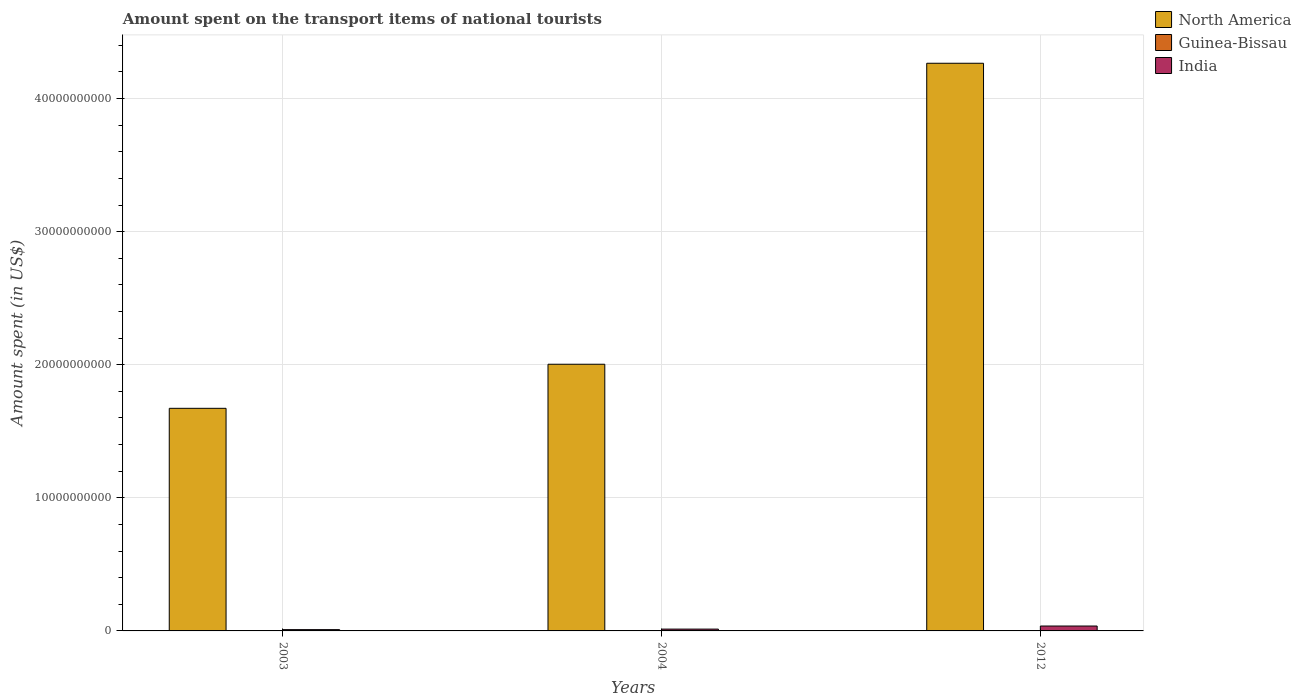Are the number of bars per tick equal to the number of legend labels?
Keep it short and to the point. Yes. Are the number of bars on each tick of the X-axis equal?
Offer a terse response. Yes. How many bars are there on the 1st tick from the left?
Your answer should be compact. 3. How many bars are there on the 3rd tick from the right?
Make the answer very short. 3. In how many cases, is the number of bars for a given year not equal to the number of legend labels?
Make the answer very short. 0. What is the amount spent on the transport items of national tourists in North America in 2004?
Keep it short and to the point. 2.00e+1. Across all years, what is the maximum amount spent on the transport items of national tourists in India?
Offer a terse response. 3.68e+08. In which year was the amount spent on the transport items of national tourists in India maximum?
Make the answer very short. 2012. What is the total amount spent on the transport items of national tourists in North America in the graph?
Ensure brevity in your answer.  7.94e+1. What is the difference between the amount spent on the transport items of national tourists in North America in 2004 and that in 2012?
Make the answer very short. -2.26e+1. What is the difference between the amount spent on the transport items of national tourists in Guinea-Bissau in 2003 and the amount spent on the transport items of national tourists in India in 2004?
Your answer should be very brief. -1.36e+08. What is the average amount spent on the transport items of national tourists in North America per year?
Offer a very short reply. 2.65e+1. In the year 2012, what is the difference between the amount spent on the transport items of national tourists in Guinea-Bissau and amount spent on the transport items of national tourists in North America?
Your answer should be very brief. -4.27e+1. In how many years, is the amount spent on the transport items of national tourists in India greater than 6000000000 US$?
Provide a short and direct response. 0. What is the ratio of the amount spent on the transport items of national tourists in India in 2004 to that in 2012?
Make the answer very short. 0.37. Is the difference between the amount spent on the transport items of national tourists in Guinea-Bissau in 2003 and 2004 greater than the difference between the amount spent on the transport items of national tourists in North America in 2003 and 2004?
Your response must be concise. Yes. What is the difference between the highest and the lowest amount spent on the transport items of national tourists in Guinea-Bissau?
Make the answer very short. 1.00e+06. What does the 2nd bar from the left in 2004 represents?
Your answer should be very brief. Guinea-Bissau. Is it the case that in every year, the sum of the amount spent on the transport items of national tourists in Guinea-Bissau and amount spent on the transport items of national tourists in India is greater than the amount spent on the transport items of national tourists in North America?
Make the answer very short. No. How many bars are there?
Give a very brief answer. 9. Are all the bars in the graph horizontal?
Your response must be concise. No. How many years are there in the graph?
Offer a terse response. 3. What is the difference between two consecutive major ticks on the Y-axis?
Ensure brevity in your answer.  1.00e+1. Are the values on the major ticks of Y-axis written in scientific E-notation?
Provide a succinct answer. No. Does the graph contain grids?
Offer a very short reply. Yes. Where does the legend appear in the graph?
Keep it short and to the point. Top right. How many legend labels are there?
Provide a short and direct response. 3. What is the title of the graph?
Your answer should be very brief. Amount spent on the transport items of national tourists. Does "Bolivia" appear as one of the legend labels in the graph?
Make the answer very short. No. What is the label or title of the Y-axis?
Keep it short and to the point. Amount spent (in US$). What is the Amount spent (in US$) in North America in 2003?
Offer a very short reply. 1.67e+1. What is the Amount spent (in US$) of Guinea-Bissau in 2003?
Provide a short and direct response. 6.00e+05. What is the Amount spent (in US$) in India in 2003?
Your answer should be very brief. 9.70e+07. What is the Amount spent (in US$) in North America in 2004?
Keep it short and to the point. 2.00e+1. What is the Amount spent (in US$) in Guinea-Bissau in 2004?
Your answer should be compact. 1.20e+06. What is the Amount spent (in US$) in India in 2004?
Your answer should be very brief. 1.37e+08. What is the Amount spent (in US$) in North America in 2012?
Ensure brevity in your answer.  4.27e+1. What is the Amount spent (in US$) in India in 2012?
Your answer should be very brief. 3.68e+08. Across all years, what is the maximum Amount spent (in US$) in North America?
Give a very brief answer. 4.27e+1. Across all years, what is the maximum Amount spent (in US$) in Guinea-Bissau?
Your answer should be compact. 1.20e+06. Across all years, what is the maximum Amount spent (in US$) in India?
Provide a short and direct response. 3.68e+08. Across all years, what is the minimum Amount spent (in US$) of North America?
Keep it short and to the point. 1.67e+1. Across all years, what is the minimum Amount spent (in US$) in Guinea-Bissau?
Ensure brevity in your answer.  2.00e+05. Across all years, what is the minimum Amount spent (in US$) in India?
Your answer should be very brief. 9.70e+07. What is the total Amount spent (in US$) of North America in the graph?
Provide a short and direct response. 7.94e+1. What is the total Amount spent (in US$) of Guinea-Bissau in the graph?
Keep it short and to the point. 2.00e+06. What is the total Amount spent (in US$) in India in the graph?
Offer a terse response. 6.02e+08. What is the difference between the Amount spent (in US$) of North America in 2003 and that in 2004?
Your answer should be very brief. -3.31e+09. What is the difference between the Amount spent (in US$) in Guinea-Bissau in 2003 and that in 2004?
Offer a very short reply. -6.00e+05. What is the difference between the Amount spent (in US$) of India in 2003 and that in 2004?
Provide a short and direct response. -4.00e+07. What is the difference between the Amount spent (in US$) of North America in 2003 and that in 2012?
Make the answer very short. -2.59e+1. What is the difference between the Amount spent (in US$) in India in 2003 and that in 2012?
Ensure brevity in your answer.  -2.71e+08. What is the difference between the Amount spent (in US$) in North America in 2004 and that in 2012?
Ensure brevity in your answer.  -2.26e+1. What is the difference between the Amount spent (in US$) of India in 2004 and that in 2012?
Offer a terse response. -2.31e+08. What is the difference between the Amount spent (in US$) of North America in 2003 and the Amount spent (in US$) of Guinea-Bissau in 2004?
Offer a terse response. 1.67e+1. What is the difference between the Amount spent (in US$) in North America in 2003 and the Amount spent (in US$) in India in 2004?
Your response must be concise. 1.66e+1. What is the difference between the Amount spent (in US$) in Guinea-Bissau in 2003 and the Amount spent (in US$) in India in 2004?
Keep it short and to the point. -1.36e+08. What is the difference between the Amount spent (in US$) of North America in 2003 and the Amount spent (in US$) of Guinea-Bissau in 2012?
Keep it short and to the point. 1.67e+1. What is the difference between the Amount spent (in US$) in North America in 2003 and the Amount spent (in US$) in India in 2012?
Your response must be concise. 1.64e+1. What is the difference between the Amount spent (in US$) of Guinea-Bissau in 2003 and the Amount spent (in US$) of India in 2012?
Ensure brevity in your answer.  -3.67e+08. What is the difference between the Amount spent (in US$) of North America in 2004 and the Amount spent (in US$) of Guinea-Bissau in 2012?
Your answer should be compact. 2.00e+1. What is the difference between the Amount spent (in US$) in North America in 2004 and the Amount spent (in US$) in India in 2012?
Your answer should be very brief. 1.97e+1. What is the difference between the Amount spent (in US$) in Guinea-Bissau in 2004 and the Amount spent (in US$) in India in 2012?
Keep it short and to the point. -3.67e+08. What is the average Amount spent (in US$) in North America per year?
Keep it short and to the point. 2.65e+1. What is the average Amount spent (in US$) of Guinea-Bissau per year?
Offer a terse response. 6.67e+05. What is the average Amount spent (in US$) in India per year?
Your answer should be very brief. 2.01e+08. In the year 2003, what is the difference between the Amount spent (in US$) in North America and Amount spent (in US$) in Guinea-Bissau?
Your response must be concise. 1.67e+1. In the year 2003, what is the difference between the Amount spent (in US$) in North America and Amount spent (in US$) in India?
Give a very brief answer. 1.66e+1. In the year 2003, what is the difference between the Amount spent (in US$) in Guinea-Bissau and Amount spent (in US$) in India?
Give a very brief answer. -9.64e+07. In the year 2004, what is the difference between the Amount spent (in US$) of North America and Amount spent (in US$) of Guinea-Bissau?
Your answer should be very brief. 2.00e+1. In the year 2004, what is the difference between the Amount spent (in US$) of North America and Amount spent (in US$) of India?
Keep it short and to the point. 1.99e+1. In the year 2004, what is the difference between the Amount spent (in US$) in Guinea-Bissau and Amount spent (in US$) in India?
Provide a short and direct response. -1.36e+08. In the year 2012, what is the difference between the Amount spent (in US$) of North America and Amount spent (in US$) of Guinea-Bissau?
Offer a very short reply. 4.27e+1. In the year 2012, what is the difference between the Amount spent (in US$) in North America and Amount spent (in US$) in India?
Keep it short and to the point. 4.23e+1. In the year 2012, what is the difference between the Amount spent (in US$) in Guinea-Bissau and Amount spent (in US$) in India?
Your response must be concise. -3.68e+08. What is the ratio of the Amount spent (in US$) of North America in 2003 to that in 2004?
Provide a short and direct response. 0.83. What is the ratio of the Amount spent (in US$) in India in 2003 to that in 2004?
Provide a short and direct response. 0.71. What is the ratio of the Amount spent (in US$) in North America in 2003 to that in 2012?
Keep it short and to the point. 0.39. What is the ratio of the Amount spent (in US$) in Guinea-Bissau in 2003 to that in 2012?
Provide a succinct answer. 3. What is the ratio of the Amount spent (in US$) in India in 2003 to that in 2012?
Your answer should be compact. 0.26. What is the ratio of the Amount spent (in US$) of North America in 2004 to that in 2012?
Provide a succinct answer. 0.47. What is the ratio of the Amount spent (in US$) in Guinea-Bissau in 2004 to that in 2012?
Keep it short and to the point. 6. What is the ratio of the Amount spent (in US$) in India in 2004 to that in 2012?
Keep it short and to the point. 0.37. What is the difference between the highest and the second highest Amount spent (in US$) of North America?
Provide a succinct answer. 2.26e+1. What is the difference between the highest and the second highest Amount spent (in US$) in India?
Make the answer very short. 2.31e+08. What is the difference between the highest and the lowest Amount spent (in US$) of North America?
Provide a succinct answer. 2.59e+1. What is the difference between the highest and the lowest Amount spent (in US$) of Guinea-Bissau?
Provide a succinct answer. 1.00e+06. What is the difference between the highest and the lowest Amount spent (in US$) of India?
Your response must be concise. 2.71e+08. 